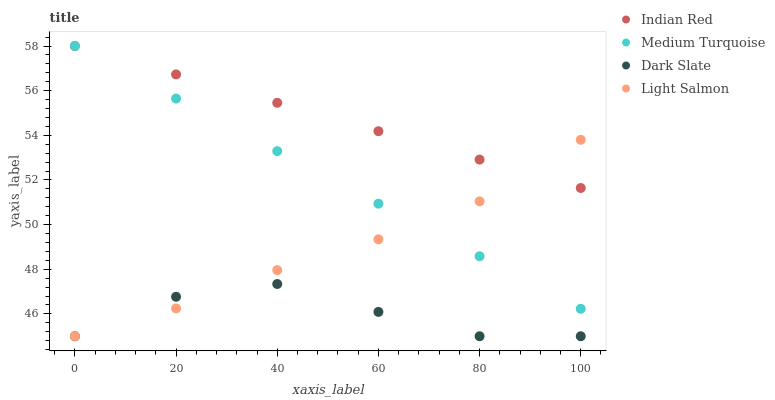Does Dark Slate have the minimum area under the curve?
Answer yes or no. Yes. Does Indian Red have the maximum area under the curve?
Answer yes or no. Yes. Does Light Salmon have the minimum area under the curve?
Answer yes or no. No. Does Light Salmon have the maximum area under the curve?
Answer yes or no. No. Is Medium Turquoise the smoothest?
Answer yes or no. Yes. Is Dark Slate the roughest?
Answer yes or no. Yes. Is Light Salmon the smoothest?
Answer yes or no. No. Is Light Salmon the roughest?
Answer yes or no. No. Does Dark Slate have the lowest value?
Answer yes or no. Yes. Does Medium Turquoise have the lowest value?
Answer yes or no. No. Does Indian Red have the highest value?
Answer yes or no. Yes. Does Light Salmon have the highest value?
Answer yes or no. No. Is Dark Slate less than Medium Turquoise?
Answer yes or no. Yes. Is Indian Red greater than Dark Slate?
Answer yes or no. Yes. Does Medium Turquoise intersect Light Salmon?
Answer yes or no. Yes. Is Medium Turquoise less than Light Salmon?
Answer yes or no. No. Is Medium Turquoise greater than Light Salmon?
Answer yes or no. No. Does Dark Slate intersect Medium Turquoise?
Answer yes or no. No. 